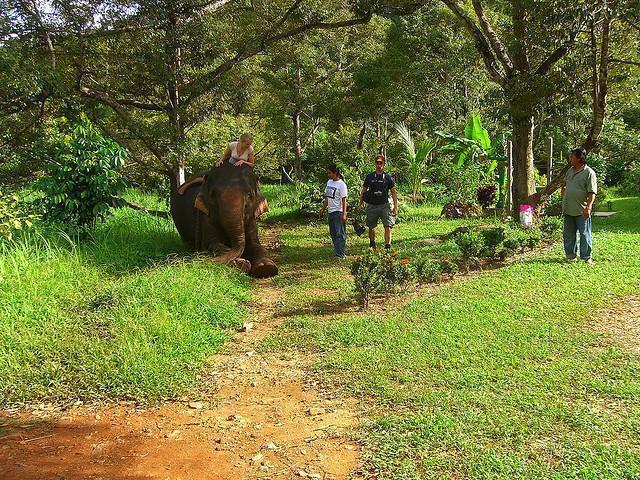Why is the elephant laying down on the left with the tourist on top?
From the following set of four choices, select the accurate answer to respond to the question.
Options: Tired, sleepy, sick, afraid. Tired. 